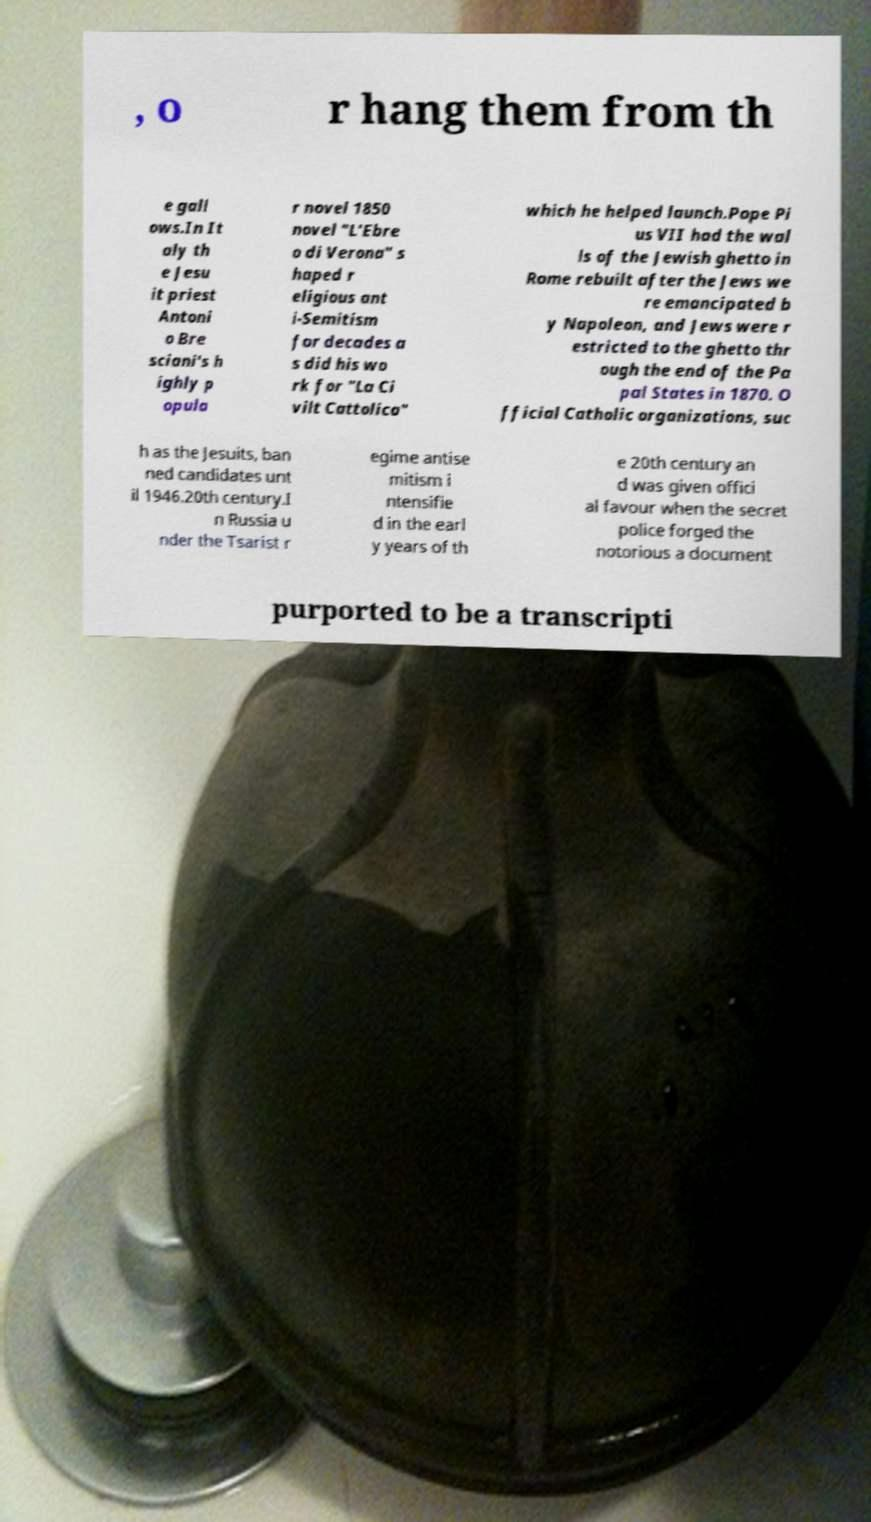There's text embedded in this image that I need extracted. Can you transcribe it verbatim? , o r hang them from th e gall ows.In It aly th e Jesu it priest Antoni o Bre sciani's h ighly p opula r novel 1850 novel "L'Ebre o di Verona" s haped r eligious ant i-Semitism for decades a s did his wo rk for "La Ci vilt Cattolica" which he helped launch.Pope Pi us VII had the wal ls of the Jewish ghetto in Rome rebuilt after the Jews we re emancipated b y Napoleon, and Jews were r estricted to the ghetto thr ough the end of the Pa pal States in 1870. O fficial Catholic organizations, suc h as the Jesuits, ban ned candidates unt il 1946.20th century.I n Russia u nder the Tsarist r egime antise mitism i ntensifie d in the earl y years of th e 20th century an d was given offici al favour when the secret police forged the notorious a document purported to be a transcripti 